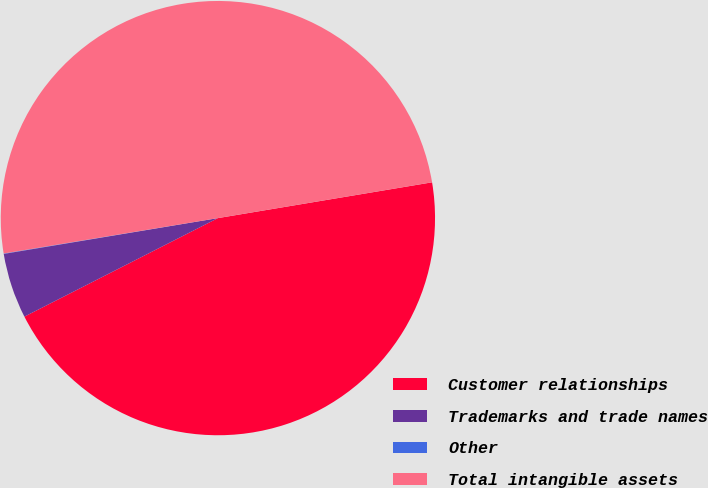<chart> <loc_0><loc_0><loc_500><loc_500><pie_chart><fcel>Customer relationships<fcel>Trademarks and trade names<fcel>Other<fcel>Total intangible assets<nl><fcel>45.14%<fcel>4.86%<fcel>0.03%<fcel>49.97%<nl></chart> 